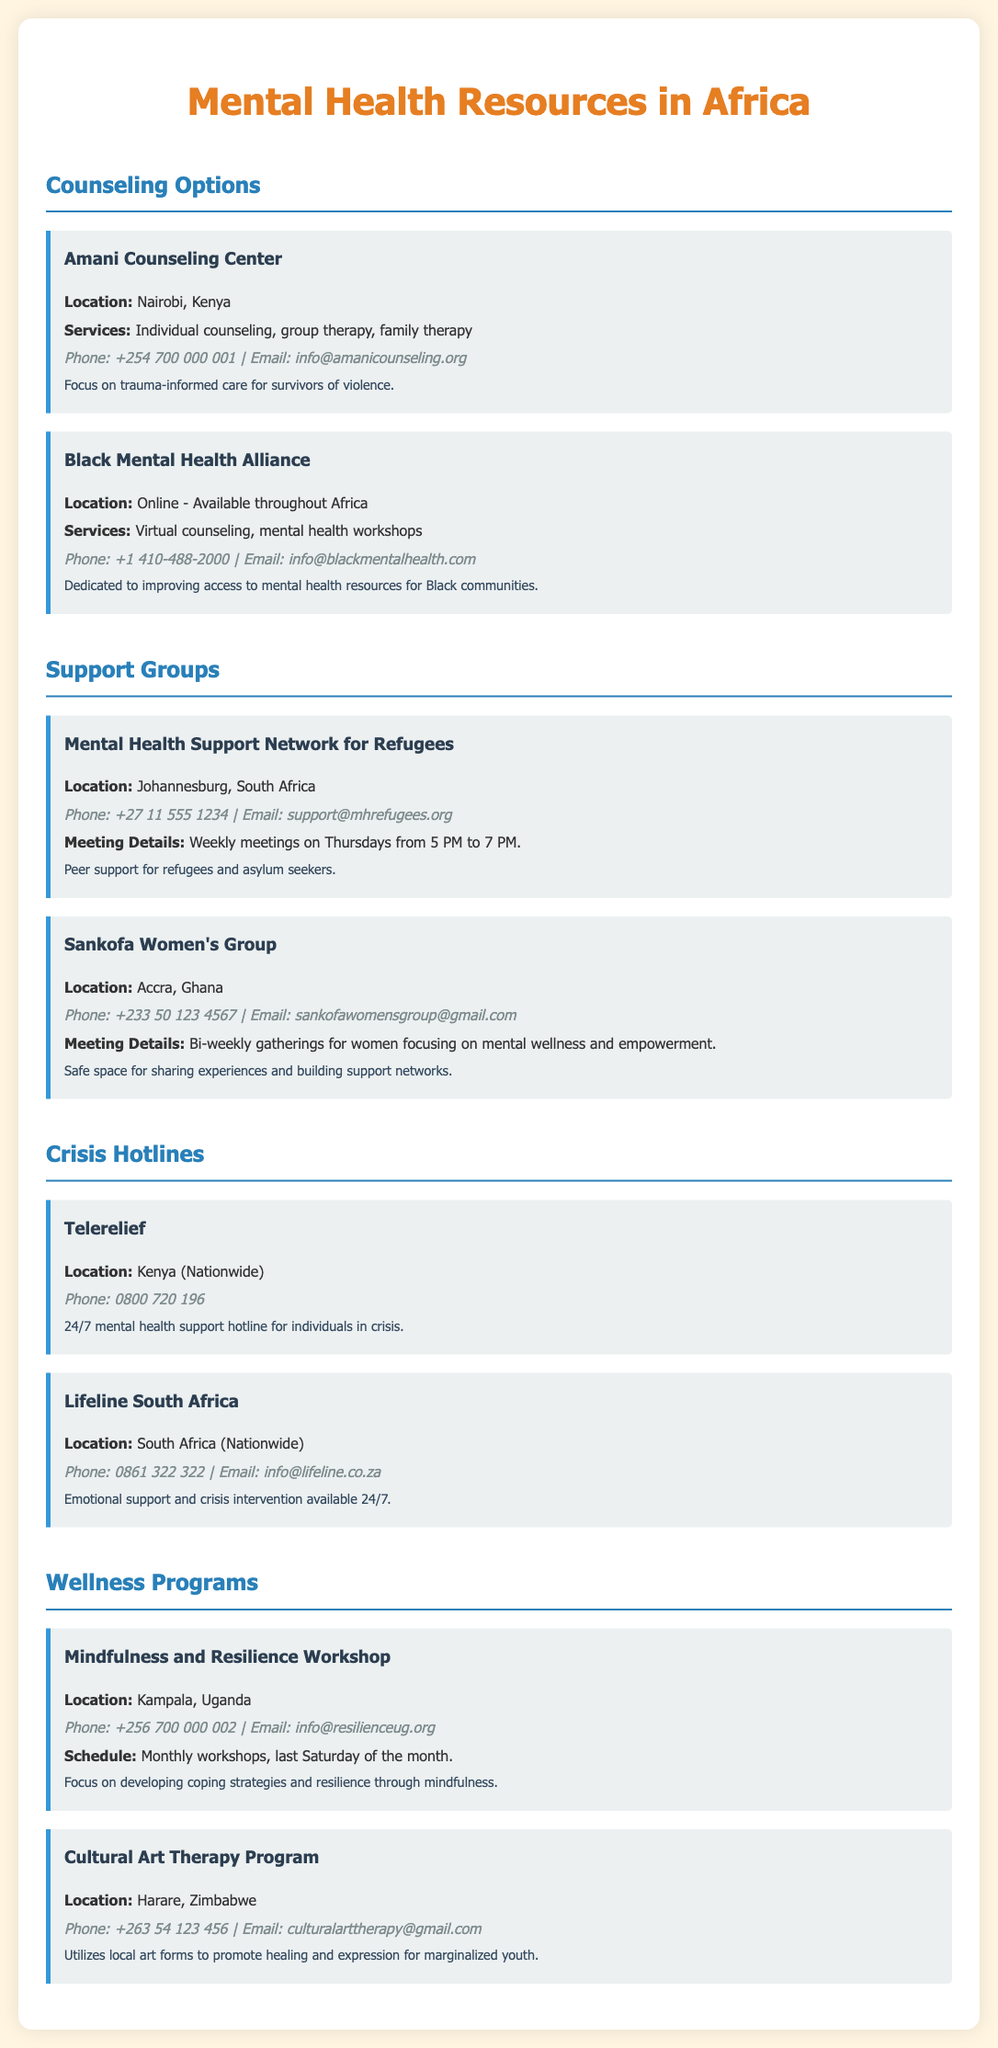What is the location of Amani Counseling Center? Amani Counseling Center is located in Nairobi, Kenya, as stated in the document.
Answer: Nairobi, Kenya What type of services does the Black Mental Health Alliance offer? The document mentions that the Black Mental Health Alliance offers virtual counseling and mental health workshops.
Answer: Virtual counseling, mental health workshops When do the Mental Health Support Network for Refugees meetings take place? The document specifies that meetings are held weekly on Thursdays from 5 PM to 7 PM.
Answer: Thursdays from 5 PM to 7 PM What phone number can be called for Telerelief? The document provides the phone number for Telerelief, which is 0800 720 196.
Answer: 0800 720 196 What is the focus of the Cultural Art Therapy Program? The document explains that the program utilizes local art forms to promote healing and expression for marginalized youth.
Answer: Healing and expression for marginalized youth How often are the Mindfulness and Resilience Workshops held? According to the document, the workshops are held monthly on the last Saturday of the month.
Answer: Monthly What type of group is Sankofa Women's Group? The document describes the Sankofa Women's Group as a safe space for sharing experiences and building support networks.
Answer: Safe space for sharing experiences What is the contact email for Lifeline South Africa? The document provides the contact email for Lifeline South Africa as info@lifeline.co.za.
Answer: info@lifeline.co.za What is the purpose of the Mental Health Support Network for Refugees? The document indicates that the purpose is to provide peer support for refugees and asylum seekers.
Answer: Peer support for refugees and asylum seekers 